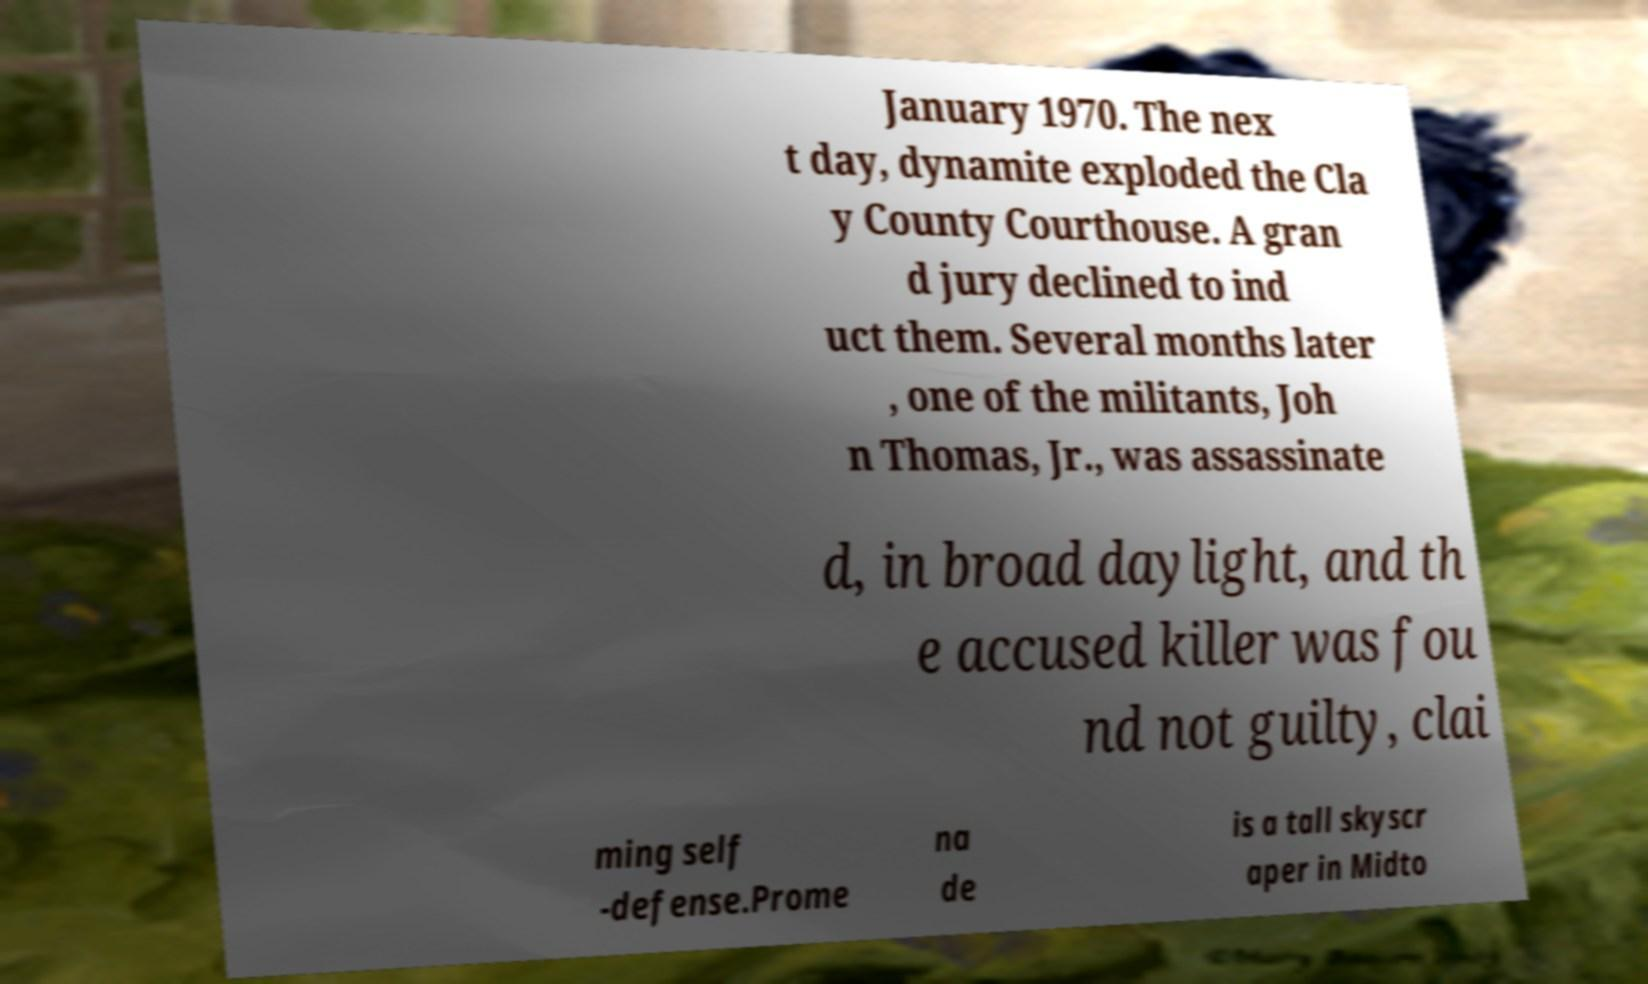Can you accurately transcribe the text from the provided image for me? January 1970. The nex t day, dynamite exploded the Cla y County Courthouse. A gran d jury declined to ind uct them. Several months later , one of the militants, Joh n Thomas, Jr., was assassinate d, in broad daylight, and th e accused killer was fou nd not guilty, clai ming self -defense.Prome na de is a tall skyscr aper in Midto 